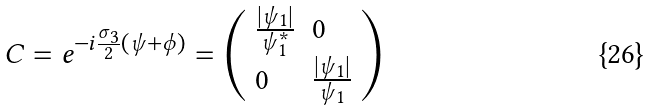<formula> <loc_0><loc_0><loc_500><loc_500>C = e ^ { - i \frac { \sigma _ { 3 } } { 2 } ( \psi + \phi ) } = \left ( \begin{array} { l l } { { \frac { | \psi _ { 1 } | } { \psi _ { 1 } ^ { * } } } } & { 0 } \\ { 0 } & { { \frac { | \psi _ { 1 } | } { \psi _ { 1 } } } } \end{array} \right )</formula> 